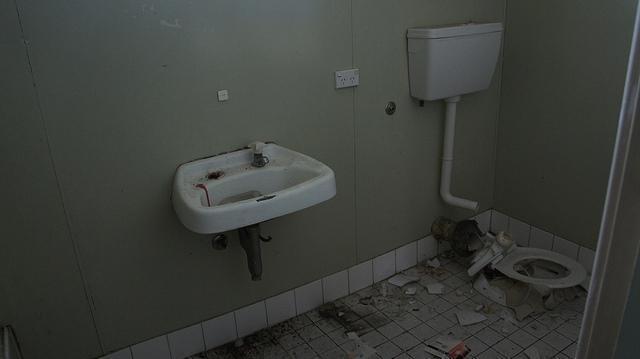How many sandwich halves?
Give a very brief answer. 0. 